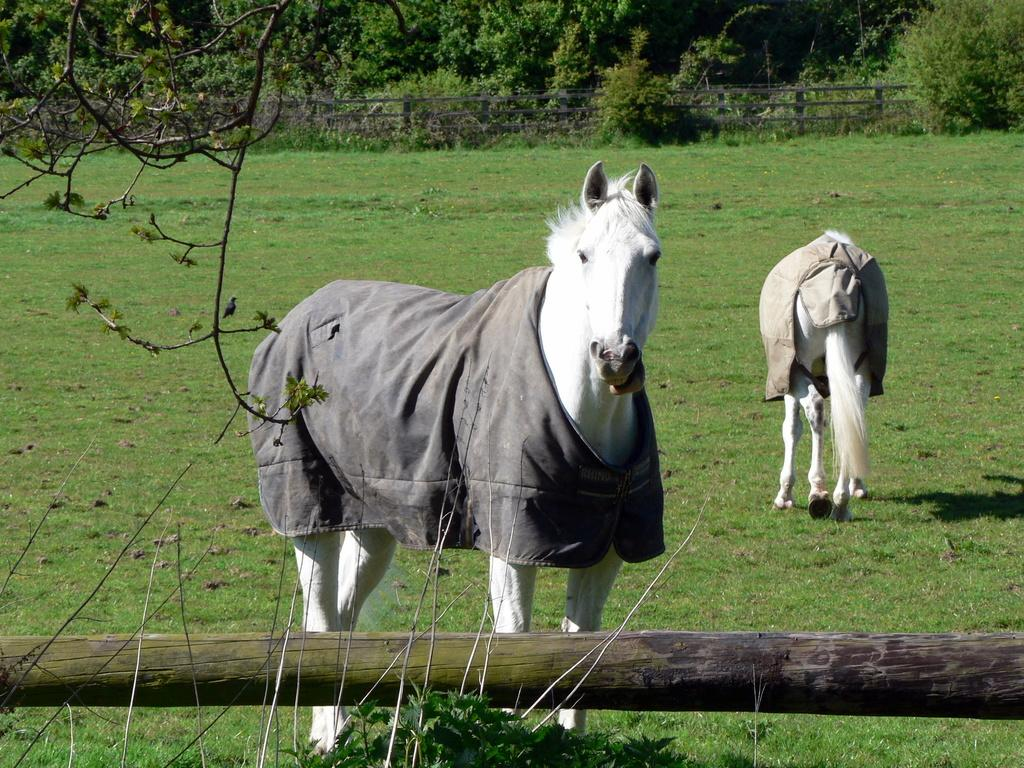What animals can be seen in the image? There are horses in the image. What are the horses wearing? The horses have clothes on their bodies. What type of vegetation is present in the image? There are trees in the image. What is the purpose of the fence in the image? The fence is likely used to contain or separate the horses from other areas. What is the ground covered with in the image? There is grass on the ground in the image. What color are the horses in the image? Both horses are white in color. What type of needle can be seen in the image? There is no needle present in the image. Is there a boat visible in the image? No, there is no boat present in the image. 